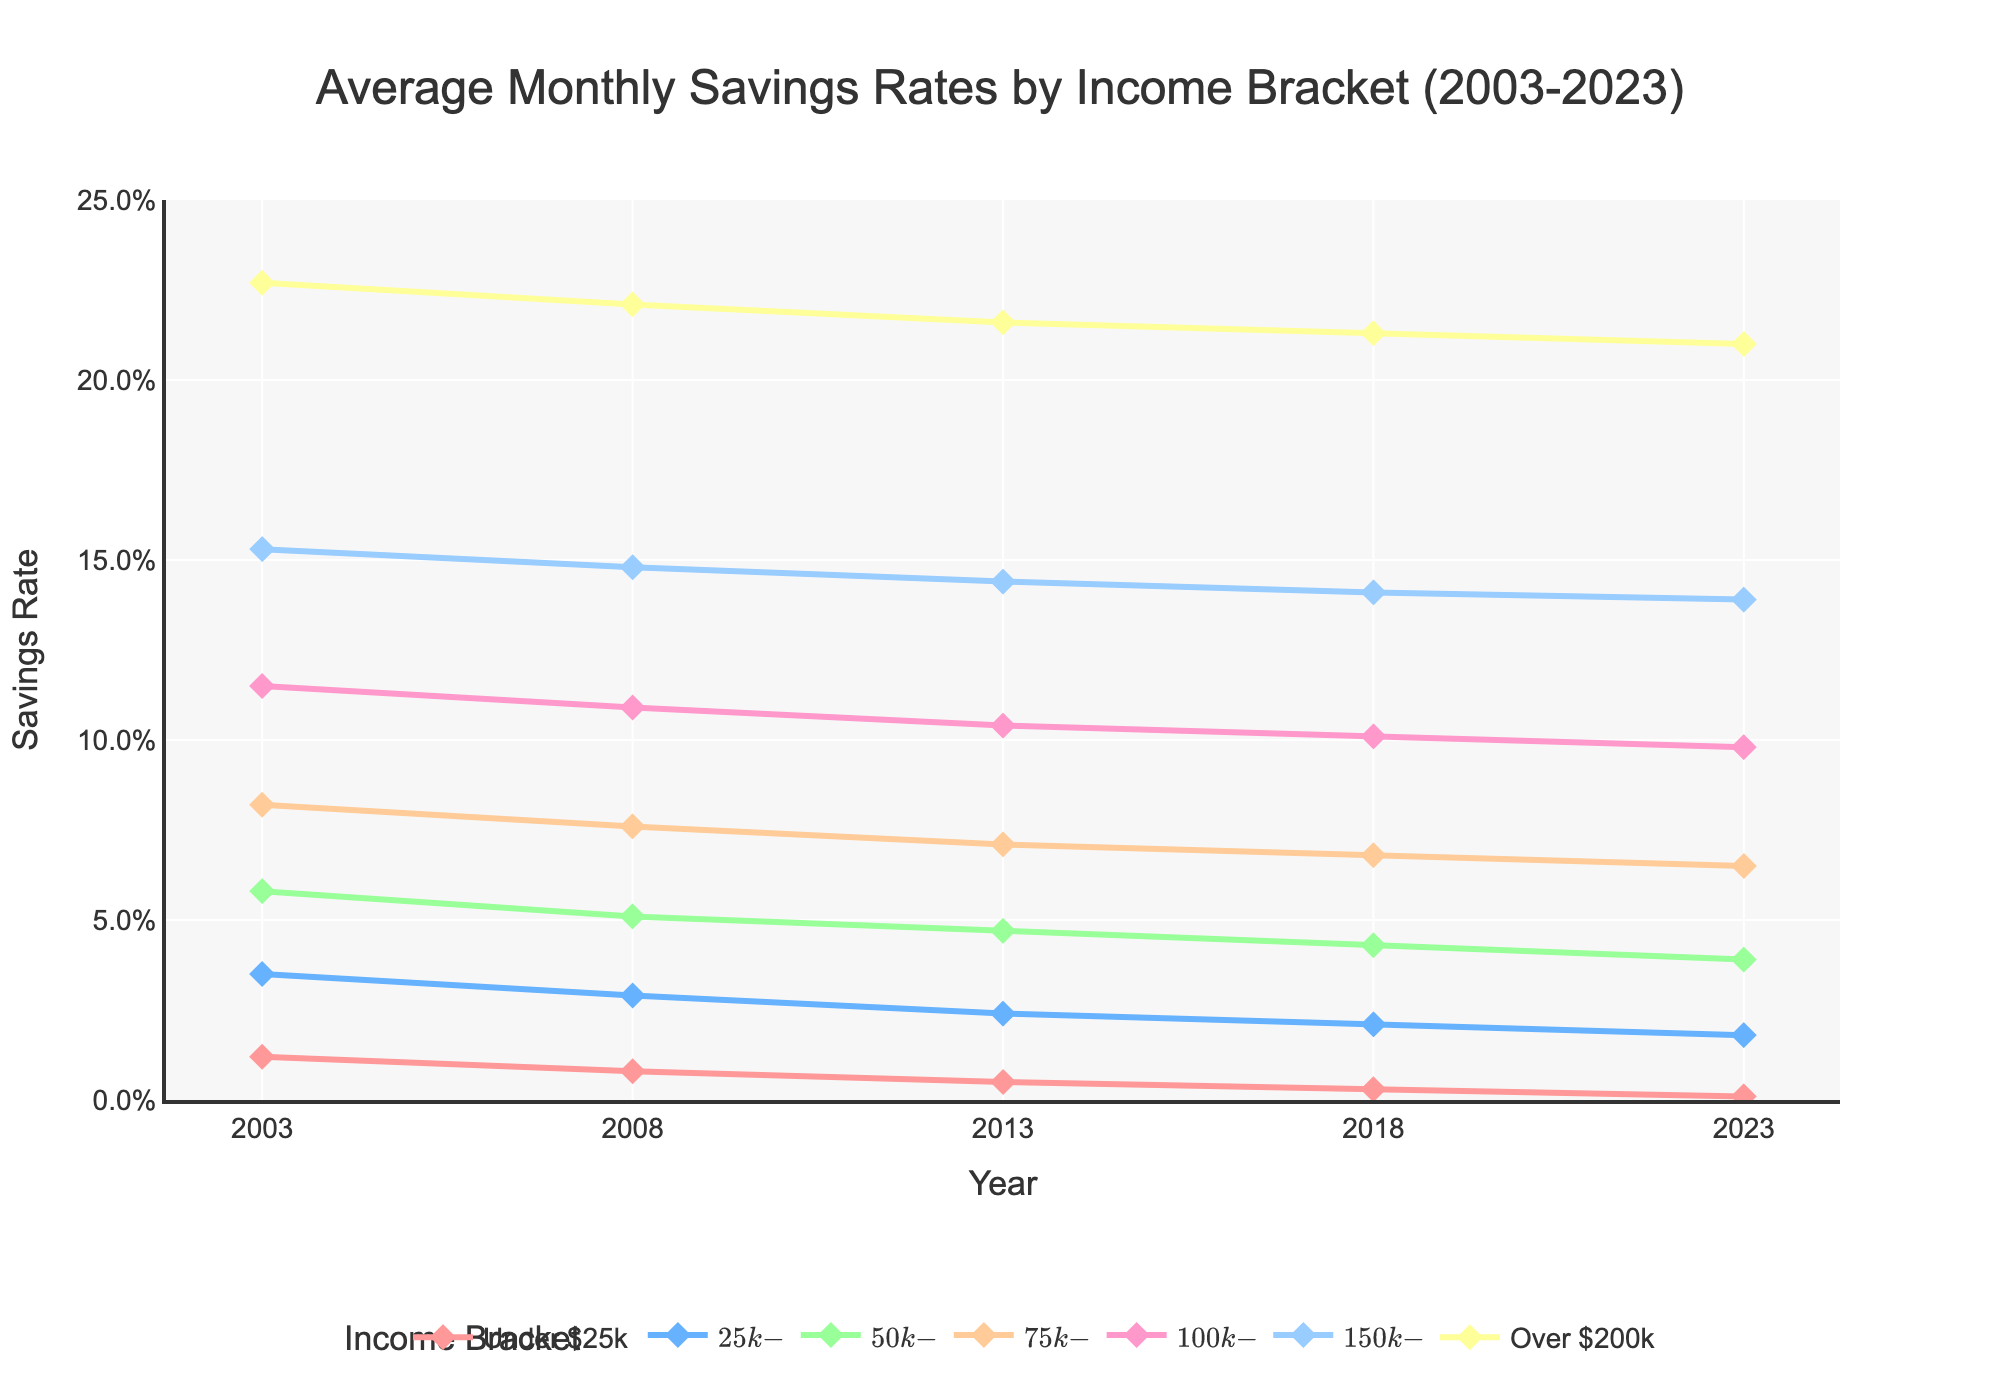What is the general trend of the savings rates for the "Under $25k" income bracket over the 20 years? The savings rate for the "Under $25k" income bracket shows a consistent decline from 1.2% in 2003 to 0.1% in 2023. This decline is progressive and constant throughout the years.
Answer: Decreasing Which income bracket experienced the least change in savings rate from 2003 to 2023? By observing the differences in savings rates from 2003 to 2023 among all income brackets, the "Over $200k" bracket has the smallest change, decreasing from 22.7% to 21.0%, which is a roughly 1.7 percentage point drop.
Answer: Over $200k Which income bracket had the highest savings rate in 2013, and what was the corresponding savings rate? By looking at the 2013 line, the "Over $200k" income bracket had the highest savings rate at 21.6%.
Answer: Over $200k, 21.6% Among the given income brackets, which showed the highest savings rate in 2023, and what was the rate? Referring to the 2023 data, the "Over $200k" income bracket had the highest savings rate at 21.0%.
Answer: Over $200k, 21.0% How did the savings rate for the "$25k-$50k" bracket change from 2008 to 2018? The savings rate for the "$25k-$50k" income bracket decreased from 2.9% in 2008 to 2.1% in 2018. This change represents a decrease of 0.8 percentage points.
Answer: Decreased by 0.8 percentage points Which two income brackets have the steepest decline in savings rate from 2003 to 2023? By calculating the differences from 2003 to 2023 for each income bracket, the "Under $25k" and "$25k-$50k" brackets experienced the steepest declines, with the "Under $25k" decreasing by 1.1 percentage points and the "$25k-$50k" decreasing by 1.7 percentage points. These represent significant drops relative to their original values.
Answer: Under $25k and $25k-$50k What was the savings rate of the "$75k-$100k" income bracket in 2008 compared to 2023? The savings rate for the "$75k-$100k" income bracket was 7.6% in 2008 and decreased to 6.5% in 2023. So, it declined by 1.1 percentage points over this time period.
Answer: 7.6% in 2008 and 6.5% in 2023 What is the approximate difference in the savings rate between the "$50k-$75k" and the "Under $25k" brackets in 2023? In 2023, the "$50k-$75k" income bracket had a savings rate of 3.9%, while the "Under $25k" bracket had 0.1%. The difference is 3.8 percentage points.
Answer: 3.8 percentage points How does the savings rate for the $100k-$150k bracket in 2018 compare to that in 2008? The savings rate for the $100k-$150k bracket was 10.9% in 2008 and slightly decreased to 10.1% in 2018, showing a decline of 0.8 percentage points.
Answer: 10.9% in 2008 and 10.1% in 2018 What is the trend in the range (difference between highest and lowest) of savings rates across all income brackets from 2003 to 2023? The range in savings rates across all income brackets in 2003 was 21.5 percentage points (22.7% - 1.2%), and in 2023 it was 20.9 percentage points (21.0% - 0.1%). The range slightly decreased over the 20 years.
Answer: Slightly decreasing 